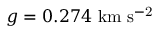<formula> <loc_0><loc_0><loc_500><loc_500>g = 0 . 2 7 4 \ k m \ s ^ { - 2 }</formula> 